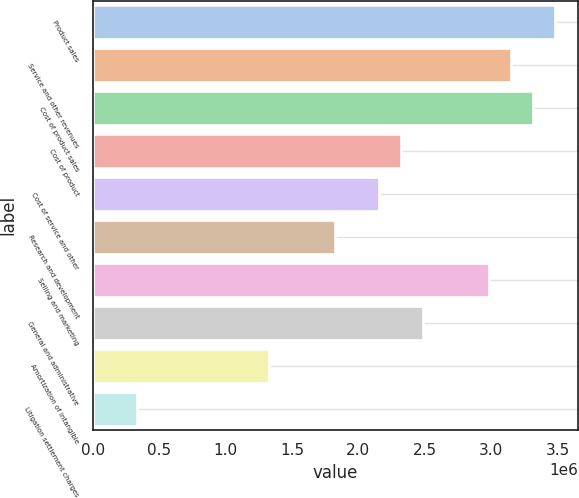<chart> <loc_0><loc_0><loc_500><loc_500><bar_chart><fcel>Product sales<fcel>Service and other revenues<fcel>Cost of product sales<fcel>Cost of product<fcel>Cost of service and other<fcel>Research and development<fcel>Selling and marketing<fcel>General and administrative<fcel>Amortization of intangible<fcel>Litigation settlement charges<nl><fcel>3.48123e+06<fcel>3.14968e+06<fcel>3.31546e+06<fcel>2.32082e+06<fcel>2.15505e+06<fcel>1.8235e+06<fcel>2.98391e+06<fcel>2.48659e+06<fcel>1.32618e+06<fcel>331546<nl></chart> 